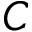<formula> <loc_0><loc_0><loc_500><loc_500>C</formula> 